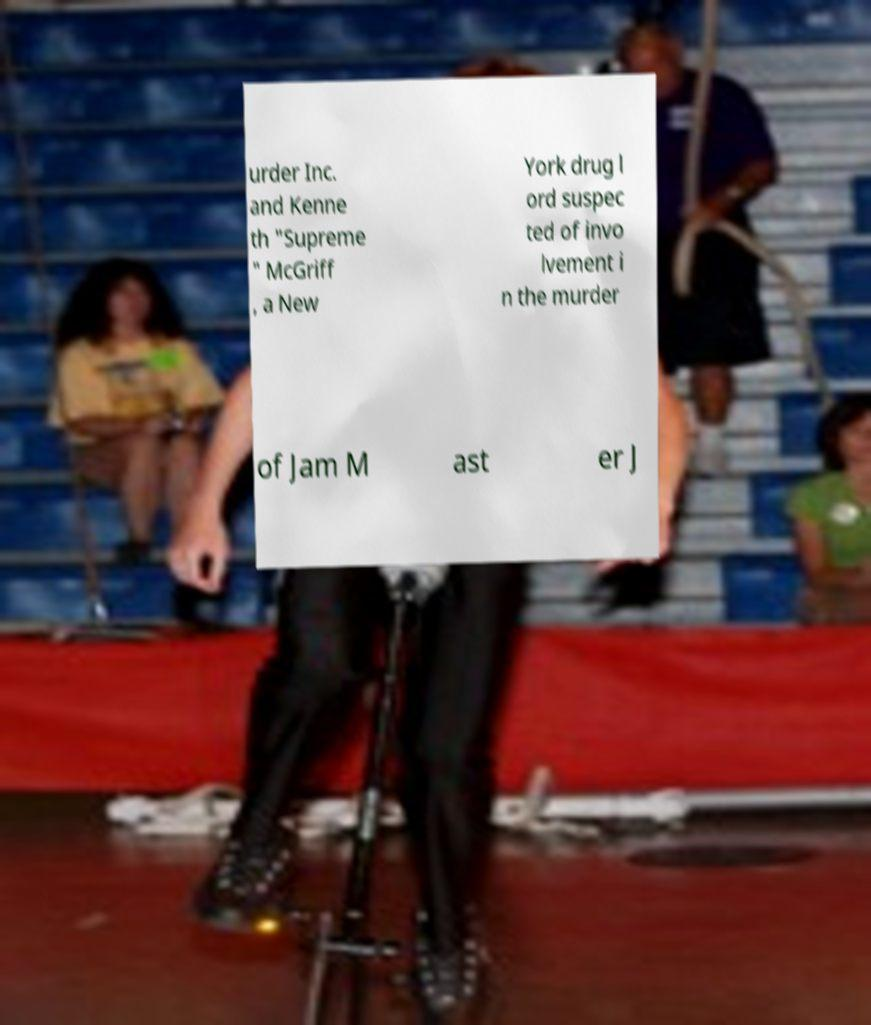Please read and relay the text visible in this image. What does it say? urder Inc. and Kenne th "Supreme " McGriff , a New York drug l ord suspec ted of invo lvement i n the murder of Jam M ast er J 